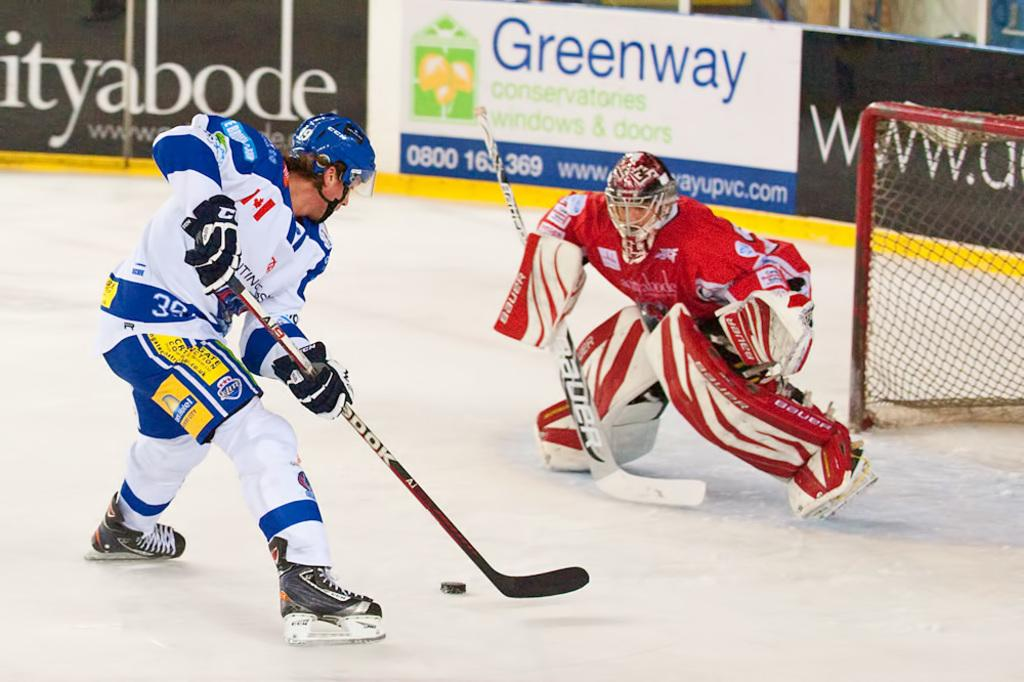<image>
Present a compact description of the photo's key features. An ice hocket game with an advert for Greenway at the back. 